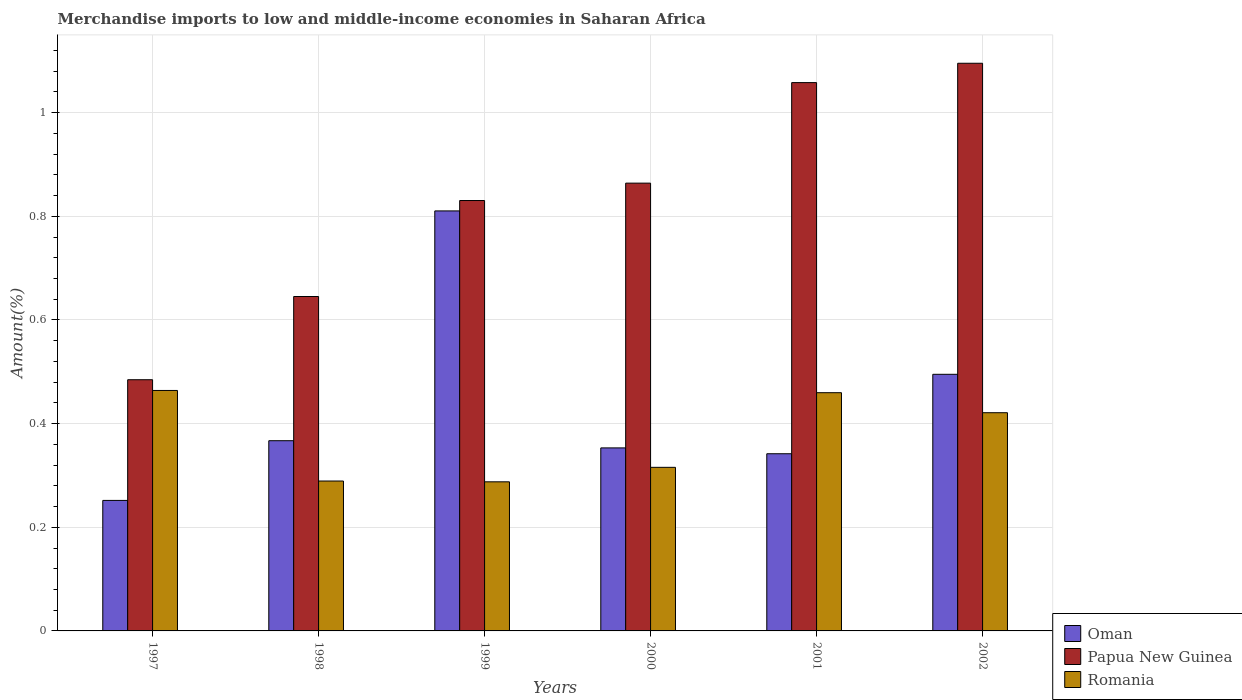How many different coloured bars are there?
Make the answer very short. 3. How many bars are there on the 1st tick from the left?
Keep it short and to the point. 3. What is the label of the 6th group of bars from the left?
Provide a succinct answer. 2002. What is the percentage of amount earned from merchandise imports in Papua New Guinea in 1998?
Offer a terse response. 0.65. Across all years, what is the maximum percentage of amount earned from merchandise imports in Papua New Guinea?
Your answer should be very brief. 1.1. Across all years, what is the minimum percentage of amount earned from merchandise imports in Oman?
Provide a short and direct response. 0.25. What is the total percentage of amount earned from merchandise imports in Oman in the graph?
Make the answer very short. 2.62. What is the difference between the percentage of amount earned from merchandise imports in Oman in 1998 and that in 2000?
Ensure brevity in your answer.  0.01. What is the difference between the percentage of amount earned from merchandise imports in Oman in 2002 and the percentage of amount earned from merchandise imports in Papua New Guinea in 1999?
Make the answer very short. -0.34. What is the average percentage of amount earned from merchandise imports in Papua New Guinea per year?
Your answer should be very brief. 0.83. In the year 2002, what is the difference between the percentage of amount earned from merchandise imports in Oman and percentage of amount earned from merchandise imports in Romania?
Offer a very short reply. 0.07. In how many years, is the percentage of amount earned from merchandise imports in Oman greater than 0.7600000000000001 %?
Provide a succinct answer. 1. What is the ratio of the percentage of amount earned from merchandise imports in Romania in 2000 to that in 2001?
Provide a succinct answer. 0.69. Is the percentage of amount earned from merchandise imports in Papua New Guinea in 1998 less than that in 2002?
Ensure brevity in your answer.  Yes. Is the difference between the percentage of amount earned from merchandise imports in Oman in 1998 and 2002 greater than the difference between the percentage of amount earned from merchandise imports in Romania in 1998 and 2002?
Give a very brief answer. Yes. What is the difference between the highest and the second highest percentage of amount earned from merchandise imports in Romania?
Offer a terse response. 0. What is the difference between the highest and the lowest percentage of amount earned from merchandise imports in Oman?
Provide a succinct answer. 0.56. Is the sum of the percentage of amount earned from merchandise imports in Oman in 1999 and 2000 greater than the maximum percentage of amount earned from merchandise imports in Romania across all years?
Make the answer very short. Yes. What does the 3rd bar from the left in 2001 represents?
Your response must be concise. Romania. What does the 1st bar from the right in 2002 represents?
Your answer should be compact. Romania. Is it the case that in every year, the sum of the percentage of amount earned from merchandise imports in Romania and percentage of amount earned from merchandise imports in Papua New Guinea is greater than the percentage of amount earned from merchandise imports in Oman?
Make the answer very short. Yes. Does the graph contain any zero values?
Your answer should be compact. No. Where does the legend appear in the graph?
Provide a succinct answer. Bottom right. What is the title of the graph?
Ensure brevity in your answer.  Merchandise imports to low and middle-income economies in Saharan Africa. Does "Bosnia and Herzegovina" appear as one of the legend labels in the graph?
Give a very brief answer. No. What is the label or title of the Y-axis?
Your answer should be very brief. Amount(%). What is the Amount(%) of Oman in 1997?
Your answer should be very brief. 0.25. What is the Amount(%) in Papua New Guinea in 1997?
Provide a short and direct response. 0.48. What is the Amount(%) of Romania in 1997?
Your answer should be very brief. 0.46. What is the Amount(%) of Oman in 1998?
Your answer should be very brief. 0.37. What is the Amount(%) in Papua New Guinea in 1998?
Ensure brevity in your answer.  0.65. What is the Amount(%) of Romania in 1998?
Your response must be concise. 0.29. What is the Amount(%) in Oman in 1999?
Offer a very short reply. 0.81. What is the Amount(%) in Papua New Guinea in 1999?
Provide a short and direct response. 0.83. What is the Amount(%) of Romania in 1999?
Provide a short and direct response. 0.29. What is the Amount(%) of Oman in 2000?
Provide a succinct answer. 0.35. What is the Amount(%) in Papua New Guinea in 2000?
Give a very brief answer. 0.86. What is the Amount(%) in Romania in 2000?
Offer a very short reply. 0.32. What is the Amount(%) of Oman in 2001?
Offer a very short reply. 0.34. What is the Amount(%) of Papua New Guinea in 2001?
Your answer should be compact. 1.06. What is the Amount(%) of Romania in 2001?
Your answer should be compact. 0.46. What is the Amount(%) of Oman in 2002?
Offer a very short reply. 0.5. What is the Amount(%) of Papua New Guinea in 2002?
Provide a short and direct response. 1.1. What is the Amount(%) of Romania in 2002?
Offer a terse response. 0.42. Across all years, what is the maximum Amount(%) in Oman?
Offer a terse response. 0.81. Across all years, what is the maximum Amount(%) in Papua New Guinea?
Your response must be concise. 1.1. Across all years, what is the maximum Amount(%) of Romania?
Make the answer very short. 0.46. Across all years, what is the minimum Amount(%) in Oman?
Make the answer very short. 0.25. Across all years, what is the minimum Amount(%) of Papua New Guinea?
Your answer should be very brief. 0.48. Across all years, what is the minimum Amount(%) in Romania?
Your answer should be very brief. 0.29. What is the total Amount(%) of Oman in the graph?
Your answer should be very brief. 2.62. What is the total Amount(%) of Papua New Guinea in the graph?
Offer a very short reply. 4.98. What is the total Amount(%) of Romania in the graph?
Your answer should be compact. 2.24. What is the difference between the Amount(%) in Oman in 1997 and that in 1998?
Your answer should be compact. -0.12. What is the difference between the Amount(%) of Papua New Guinea in 1997 and that in 1998?
Ensure brevity in your answer.  -0.16. What is the difference between the Amount(%) of Romania in 1997 and that in 1998?
Give a very brief answer. 0.17. What is the difference between the Amount(%) in Oman in 1997 and that in 1999?
Give a very brief answer. -0.56. What is the difference between the Amount(%) of Papua New Guinea in 1997 and that in 1999?
Offer a very short reply. -0.35. What is the difference between the Amount(%) in Romania in 1997 and that in 1999?
Ensure brevity in your answer.  0.18. What is the difference between the Amount(%) of Oman in 1997 and that in 2000?
Offer a very short reply. -0.1. What is the difference between the Amount(%) in Papua New Guinea in 1997 and that in 2000?
Give a very brief answer. -0.38. What is the difference between the Amount(%) in Romania in 1997 and that in 2000?
Provide a short and direct response. 0.15. What is the difference between the Amount(%) of Oman in 1997 and that in 2001?
Keep it short and to the point. -0.09. What is the difference between the Amount(%) of Papua New Guinea in 1997 and that in 2001?
Offer a very short reply. -0.57. What is the difference between the Amount(%) in Romania in 1997 and that in 2001?
Make the answer very short. 0. What is the difference between the Amount(%) in Oman in 1997 and that in 2002?
Provide a succinct answer. -0.24. What is the difference between the Amount(%) of Papua New Guinea in 1997 and that in 2002?
Ensure brevity in your answer.  -0.61. What is the difference between the Amount(%) of Romania in 1997 and that in 2002?
Make the answer very short. 0.04. What is the difference between the Amount(%) of Oman in 1998 and that in 1999?
Your answer should be compact. -0.44. What is the difference between the Amount(%) in Papua New Guinea in 1998 and that in 1999?
Provide a succinct answer. -0.19. What is the difference between the Amount(%) of Romania in 1998 and that in 1999?
Offer a terse response. 0. What is the difference between the Amount(%) in Oman in 1998 and that in 2000?
Offer a terse response. 0.01. What is the difference between the Amount(%) in Papua New Guinea in 1998 and that in 2000?
Make the answer very short. -0.22. What is the difference between the Amount(%) of Romania in 1998 and that in 2000?
Ensure brevity in your answer.  -0.03. What is the difference between the Amount(%) of Oman in 1998 and that in 2001?
Your answer should be compact. 0.03. What is the difference between the Amount(%) of Papua New Guinea in 1998 and that in 2001?
Offer a very short reply. -0.41. What is the difference between the Amount(%) of Romania in 1998 and that in 2001?
Offer a terse response. -0.17. What is the difference between the Amount(%) in Oman in 1998 and that in 2002?
Your response must be concise. -0.13. What is the difference between the Amount(%) of Papua New Guinea in 1998 and that in 2002?
Provide a succinct answer. -0.45. What is the difference between the Amount(%) of Romania in 1998 and that in 2002?
Offer a very short reply. -0.13. What is the difference between the Amount(%) in Oman in 1999 and that in 2000?
Provide a succinct answer. 0.46. What is the difference between the Amount(%) in Papua New Guinea in 1999 and that in 2000?
Your answer should be compact. -0.03. What is the difference between the Amount(%) in Romania in 1999 and that in 2000?
Your answer should be compact. -0.03. What is the difference between the Amount(%) in Oman in 1999 and that in 2001?
Your answer should be very brief. 0.47. What is the difference between the Amount(%) of Papua New Guinea in 1999 and that in 2001?
Your answer should be compact. -0.23. What is the difference between the Amount(%) of Romania in 1999 and that in 2001?
Your answer should be very brief. -0.17. What is the difference between the Amount(%) in Oman in 1999 and that in 2002?
Provide a short and direct response. 0.32. What is the difference between the Amount(%) in Papua New Guinea in 1999 and that in 2002?
Give a very brief answer. -0.26. What is the difference between the Amount(%) in Romania in 1999 and that in 2002?
Provide a succinct answer. -0.13. What is the difference between the Amount(%) in Oman in 2000 and that in 2001?
Your answer should be compact. 0.01. What is the difference between the Amount(%) of Papua New Guinea in 2000 and that in 2001?
Ensure brevity in your answer.  -0.19. What is the difference between the Amount(%) of Romania in 2000 and that in 2001?
Your answer should be compact. -0.14. What is the difference between the Amount(%) of Oman in 2000 and that in 2002?
Make the answer very short. -0.14. What is the difference between the Amount(%) in Papua New Guinea in 2000 and that in 2002?
Ensure brevity in your answer.  -0.23. What is the difference between the Amount(%) in Romania in 2000 and that in 2002?
Ensure brevity in your answer.  -0.11. What is the difference between the Amount(%) in Oman in 2001 and that in 2002?
Offer a very short reply. -0.15. What is the difference between the Amount(%) of Papua New Guinea in 2001 and that in 2002?
Make the answer very short. -0.04. What is the difference between the Amount(%) in Romania in 2001 and that in 2002?
Your answer should be compact. 0.04. What is the difference between the Amount(%) in Oman in 1997 and the Amount(%) in Papua New Guinea in 1998?
Your answer should be very brief. -0.39. What is the difference between the Amount(%) of Oman in 1997 and the Amount(%) of Romania in 1998?
Keep it short and to the point. -0.04. What is the difference between the Amount(%) in Papua New Guinea in 1997 and the Amount(%) in Romania in 1998?
Provide a succinct answer. 0.2. What is the difference between the Amount(%) of Oman in 1997 and the Amount(%) of Papua New Guinea in 1999?
Offer a terse response. -0.58. What is the difference between the Amount(%) of Oman in 1997 and the Amount(%) of Romania in 1999?
Keep it short and to the point. -0.04. What is the difference between the Amount(%) in Papua New Guinea in 1997 and the Amount(%) in Romania in 1999?
Ensure brevity in your answer.  0.2. What is the difference between the Amount(%) in Oman in 1997 and the Amount(%) in Papua New Guinea in 2000?
Your answer should be compact. -0.61. What is the difference between the Amount(%) of Oman in 1997 and the Amount(%) of Romania in 2000?
Provide a succinct answer. -0.06. What is the difference between the Amount(%) in Papua New Guinea in 1997 and the Amount(%) in Romania in 2000?
Offer a terse response. 0.17. What is the difference between the Amount(%) in Oman in 1997 and the Amount(%) in Papua New Guinea in 2001?
Offer a terse response. -0.81. What is the difference between the Amount(%) in Oman in 1997 and the Amount(%) in Romania in 2001?
Make the answer very short. -0.21. What is the difference between the Amount(%) in Papua New Guinea in 1997 and the Amount(%) in Romania in 2001?
Keep it short and to the point. 0.03. What is the difference between the Amount(%) of Oman in 1997 and the Amount(%) of Papua New Guinea in 2002?
Your answer should be compact. -0.84. What is the difference between the Amount(%) of Oman in 1997 and the Amount(%) of Romania in 2002?
Ensure brevity in your answer.  -0.17. What is the difference between the Amount(%) in Papua New Guinea in 1997 and the Amount(%) in Romania in 2002?
Offer a very short reply. 0.06. What is the difference between the Amount(%) of Oman in 1998 and the Amount(%) of Papua New Guinea in 1999?
Your answer should be compact. -0.46. What is the difference between the Amount(%) of Oman in 1998 and the Amount(%) of Romania in 1999?
Give a very brief answer. 0.08. What is the difference between the Amount(%) of Papua New Guinea in 1998 and the Amount(%) of Romania in 1999?
Offer a terse response. 0.36. What is the difference between the Amount(%) in Oman in 1998 and the Amount(%) in Papua New Guinea in 2000?
Your answer should be very brief. -0.5. What is the difference between the Amount(%) of Oman in 1998 and the Amount(%) of Romania in 2000?
Provide a short and direct response. 0.05. What is the difference between the Amount(%) in Papua New Guinea in 1998 and the Amount(%) in Romania in 2000?
Offer a very short reply. 0.33. What is the difference between the Amount(%) of Oman in 1998 and the Amount(%) of Papua New Guinea in 2001?
Make the answer very short. -0.69. What is the difference between the Amount(%) in Oman in 1998 and the Amount(%) in Romania in 2001?
Ensure brevity in your answer.  -0.09. What is the difference between the Amount(%) in Papua New Guinea in 1998 and the Amount(%) in Romania in 2001?
Give a very brief answer. 0.19. What is the difference between the Amount(%) of Oman in 1998 and the Amount(%) of Papua New Guinea in 2002?
Provide a succinct answer. -0.73. What is the difference between the Amount(%) of Oman in 1998 and the Amount(%) of Romania in 2002?
Give a very brief answer. -0.05. What is the difference between the Amount(%) of Papua New Guinea in 1998 and the Amount(%) of Romania in 2002?
Your response must be concise. 0.22. What is the difference between the Amount(%) in Oman in 1999 and the Amount(%) in Papua New Guinea in 2000?
Offer a very short reply. -0.05. What is the difference between the Amount(%) in Oman in 1999 and the Amount(%) in Romania in 2000?
Your response must be concise. 0.49. What is the difference between the Amount(%) of Papua New Guinea in 1999 and the Amount(%) of Romania in 2000?
Offer a very short reply. 0.51. What is the difference between the Amount(%) in Oman in 1999 and the Amount(%) in Papua New Guinea in 2001?
Keep it short and to the point. -0.25. What is the difference between the Amount(%) in Oman in 1999 and the Amount(%) in Romania in 2001?
Provide a short and direct response. 0.35. What is the difference between the Amount(%) in Papua New Guinea in 1999 and the Amount(%) in Romania in 2001?
Provide a succinct answer. 0.37. What is the difference between the Amount(%) of Oman in 1999 and the Amount(%) of Papua New Guinea in 2002?
Provide a succinct answer. -0.28. What is the difference between the Amount(%) of Oman in 1999 and the Amount(%) of Romania in 2002?
Make the answer very short. 0.39. What is the difference between the Amount(%) in Papua New Guinea in 1999 and the Amount(%) in Romania in 2002?
Provide a succinct answer. 0.41. What is the difference between the Amount(%) in Oman in 2000 and the Amount(%) in Papua New Guinea in 2001?
Provide a short and direct response. -0.7. What is the difference between the Amount(%) in Oman in 2000 and the Amount(%) in Romania in 2001?
Offer a very short reply. -0.11. What is the difference between the Amount(%) of Papua New Guinea in 2000 and the Amount(%) of Romania in 2001?
Your answer should be very brief. 0.4. What is the difference between the Amount(%) in Oman in 2000 and the Amount(%) in Papua New Guinea in 2002?
Make the answer very short. -0.74. What is the difference between the Amount(%) in Oman in 2000 and the Amount(%) in Romania in 2002?
Offer a very short reply. -0.07. What is the difference between the Amount(%) in Papua New Guinea in 2000 and the Amount(%) in Romania in 2002?
Keep it short and to the point. 0.44. What is the difference between the Amount(%) of Oman in 2001 and the Amount(%) of Papua New Guinea in 2002?
Make the answer very short. -0.75. What is the difference between the Amount(%) in Oman in 2001 and the Amount(%) in Romania in 2002?
Offer a very short reply. -0.08. What is the difference between the Amount(%) in Papua New Guinea in 2001 and the Amount(%) in Romania in 2002?
Your answer should be compact. 0.64. What is the average Amount(%) of Oman per year?
Your answer should be very brief. 0.44. What is the average Amount(%) of Papua New Guinea per year?
Make the answer very short. 0.83. What is the average Amount(%) in Romania per year?
Offer a terse response. 0.37. In the year 1997, what is the difference between the Amount(%) of Oman and Amount(%) of Papua New Guinea?
Your answer should be very brief. -0.23. In the year 1997, what is the difference between the Amount(%) in Oman and Amount(%) in Romania?
Make the answer very short. -0.21. In the year 1997, what is the difference between the Amount(%) of Papua New Guinea and Amount(%) of Romania?
Keep it short and to the point. 0.02. In the year 1998, what is the difference between the Amount(%) in Oman and Amount(%) in Papua New Guinea?
Your answer should be very brief. -0.28. In the year 1998, what is the difference between the Amount(%) in Oman and Amount(%) in Romania?
Your answer should be compact. 0.08. In the year 1998, what is the difference between the Amount(%) of Papua New Guinea and Amount(%) of Romania?
Your response must be concise. 0.36. In the year 1999, what is the difference between the Amount(%) of Oman and Amount(%) of Papua New Guinea?
Offer a very short reply. -0.02. In the year 1999, what is the difference between the Amount(%) in Oman and Amount(%) in Romania?
Your answer should be compact. 0.52. In the year 1999, what is the difference between the Amount(%) of Papua New Guinea and Amount(%) of Romania?
Provide a short and direct response. 0.54. In the year 2000, what is the difference between the Amount(%) in Oman and Amount(%) in Papua New Guinea?
Make the answer very short. -0.51. In the year 2000, what is the difference between the Amount(%) in Oman and Amount(%) in Romania?
Offer a terse response. 0.04. In the year 2000, what is the difference between the Amount(%) of Papua New Guinea and Amount(%) of Romania?
Keep it short and to the point. 0.55. In the year 2001, what is the difference between the Amount(%) in Oman and Amount(%) in Papua New Guinea?
Your response must be concise. -0.72. In the year 2001, what is the difference between the Amount(%) in Oman and Amount(%) in Romania?
Make the answer very short. -0.12. In the year 2001, what is the difference between the Amount(%) of Papua New Guinea and Amount(%) of Romania?
Make the answer very short. 0.6. In the year 2002, what is the difference between the Amount(%) in Oman and Amount(%) in Papua New Guinea?
Make the answer very short. -0.6. In the year 2002, what is the difference between the Amount(%) in Oman and Amount(%) in Romania?
Ensure brevity in your answer.  0.07. In the year 2002, what is the difference between the Amount(%) of Papua New Guinea and Amount(%) of Romania?
Offer a terse response. 0.67. What is the ratio of the Amount(%) of Oman in 1997 to that in 1998?
Make the answer very short. 0.69. What is the ratio of the Amount(%) of Papua New Guinea in 1997 to that in 1998?
Your answer should be compact. 0.75. What is the ratio of the Amount(%) of Romania in 1997 to that in 1998?
Give a very brief answer. 1.6. What is the ratio of the Amount(%) in Oman in 1997 to that in 1999?
Offer a very short reply. 0.31. What is the ratio of the Amount(%) of Papua New Guinea in 1997 to that in 1999?
Provide a succinct answer. 0.58. What is the ratio of the Amount(%) of Romania in 1997 to that in 1999?
Offer a terse response. 1.61. What is the ratio of the Amount(%) of Oman in 1997 to that in 2000?
Your response must be concise. 0.71. What is the ratio of the Amount(%) in Papua New Guinea in 1997 to that in 2000?
Your response must be concise. 0.56. What is the ratio of the Amount(%) of Romania in 1997 to that in 2000?
Provide a succinct answer. 1.47. What is the ratio of the Amount(%) in Oman in 1997 to that in 2001?
Provide a short and direct response. 0.74. What is the ratio of the Amount(%) in Papua New Guinea in 1997 to that in 2001?
Provide a short and direct response. 0.46. What is the ratio of the Amount(%) of Romania in 1997 to that in 2001?
Your answer should be very brief. 1.01. What is the ratio of the Amount(%) of Oman in 1997 to that in 2002?
Your answer should be compact. 0.51. What is the ratio of the Amount(%) in Papua New Guinea in 1997 to that in 2002?
Provide a short and direct response. 0.44. What is the ratio of the Amount(%) in Romania in 1997 to that in 2002?
Ensure brevity in your answer.  1.1. What is the ratio of the Amount(%) of Oman in 1998 to that in 1999?
Give a very brief answer. 0.45. What is the ratio of the Amount(%) of Papua New Guinea in 1998 to that in 1999?
Ensure brevity in your answer.  0.78. What is the ratio of the Amount(%) of Oman in 1998 to that in 2000?
Offer a terse response. 1.04. What is the ratio of the Amount(%) in Papua New Guinea in 1998 to that in 2000?
Your answer should be very brief. 0.75. What is the ratio of the Amount(%) in Romania in 1998 to that in 2000?
Keep it short and to the point. 0.92. What is the ratio of the Amount(%) of Oman in 1998 to that in 2001?
Ensure brevity in your answer.  1.07. What is the ratio of the Amount(%) in Papua New Guinea in 1998 to that in 2001?
Offer a terse response. 0.61. What is the ratio of the Amount(%) in Romania in 1998 to that in 2001?
Provide a succinct answer. 0.63. What is the ratio of the Amount(%) of Oman in 1998 to that in 2002?
Your response must be concise. 0.74. What is the ratio of the Amount(%) of Papua New Guinea in 1998 to that in 2002?
Make the answer very short. 0.59. What is the ratio of the Amount(%) of Romania in 1998 to that in 2002?
Provide a short and direct response. 0.69. What is the ratio of the Amount(%) of Oman in 1999 to that in 2000?
Offer a terse response. 2.29. What is the ratio of the Amount(%) of Papua New Guinea in 1999 to that in 2000?
Give a very brief answer. 0.96. What is the ratio of the Amount(%) in Romania in 1999 to that in 2000?
Provide a succinct answer. 0.91. What is the ratio of the Amount(%) of Oman in 1999 to that in 2001?
Ensure brevity in your answer.  2.37. What is the ratio of the Amount(%) in Papua New Guinea in 1999 to that in 2001?
Provide a succinct answer. 0.79. What is the ratio of the Amount(%) of Romania in 1999 to that in 2001?
Keep it short and to the point. 0.63. What is the ratio of the Amount(%) of Oman in 1999 to that in 2002?
Offer a terse response. 1.64. What is the ratio of the Amount(%) in Papua New Guinea in 1999 to that in 2002?
Give a very brief answer. 0.76. What is the ratio of the Amount(%) in Romania in 1999 to that in 2002?
Make the answer very short. 0.68. What is the ratio of the Amount(%) in Oman in 2000 to that in 2001?
Your answer should be very brief. 1.03. What is the ratio of the Amount(%) of Papua New Guinea in 2000 to that in 2001?
Offer a very short reply. 0.82. What is the ratio of the Amount(%) in Romania in 2000 to that in 2001?
Make the answer very short. 0.69. What is the ratio of the Amount(%) in Oman in 2000 to that in 2002?
Offer a terse response. 0.71. What is the ratio of the Amount(%) of Papua New Guinea in 2000 to that in 2002?
Offer a terse response. 0.79. What is the ratio of the Amount(%) of Romania in 2000 to that in 2002?
Ensure brevity in your answer.  0.75. What is the ratio of the Amount(%) in Oman in 2001 to that in 2002?
Give a very brief answer. 0.69. What is the ratio of the Amount(%) of Papua New Guinea in 2001 to that in 2002?
Ensure brevity in your answer.  0.97. What is the ratio of the Amount(%) of Romania in 2001 to that in 2002?
Give a very brief answer. 1.09. What is the difference between the highest and the second highest Amount(%) in Oman?
Ensure brevity in your answer.  0.32. What is the difference between the highest and the second highest Amount(%) of Papua New Guinea?
Keep it short and to the point. 0.04. What is the difference between the highest and the second highest Amount(%) in Romania?
Make the answer very short. 0. What is the difference between the highest and the lowest Amount(%) in Oman?
Offer a terse response. 0.56. What is the difference between the highest and the lowest Amount(%) in Papua New Guinea?
Offer a terse response. 0.61. What is the difference between the highest and the lowest Amount(%) of Romania?
Your answer should be compact. 0.18. 